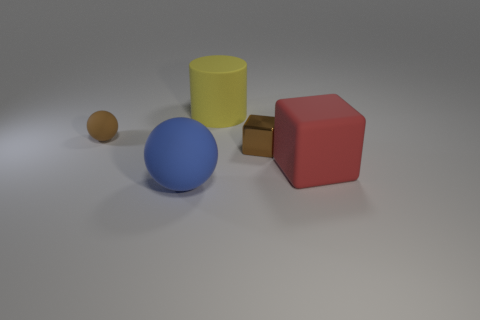Add 1 yellow rubber cylinders. How many objects exist? 6 Subtract all red cubes. How many cubes are left? 1 Subtract 1 spheres. How many spheres are left? 1 Subtract all blue spheres. How many red blocks are left? 1 Subtract all balls. Subtract all large matte cubes. How many objects are left? 2 Add 2 small brown spheres. How many small brown spheres are left? 3 Add 4 small rubber balls. How many small rubber balls exist? 5 Subtract 0 purple spheres. How many objects are left? 5 Subtract all spheres. How many objects are left? 3 Subtract all brown cubes. Subtract all green spheres. How many cubes are left? 1 